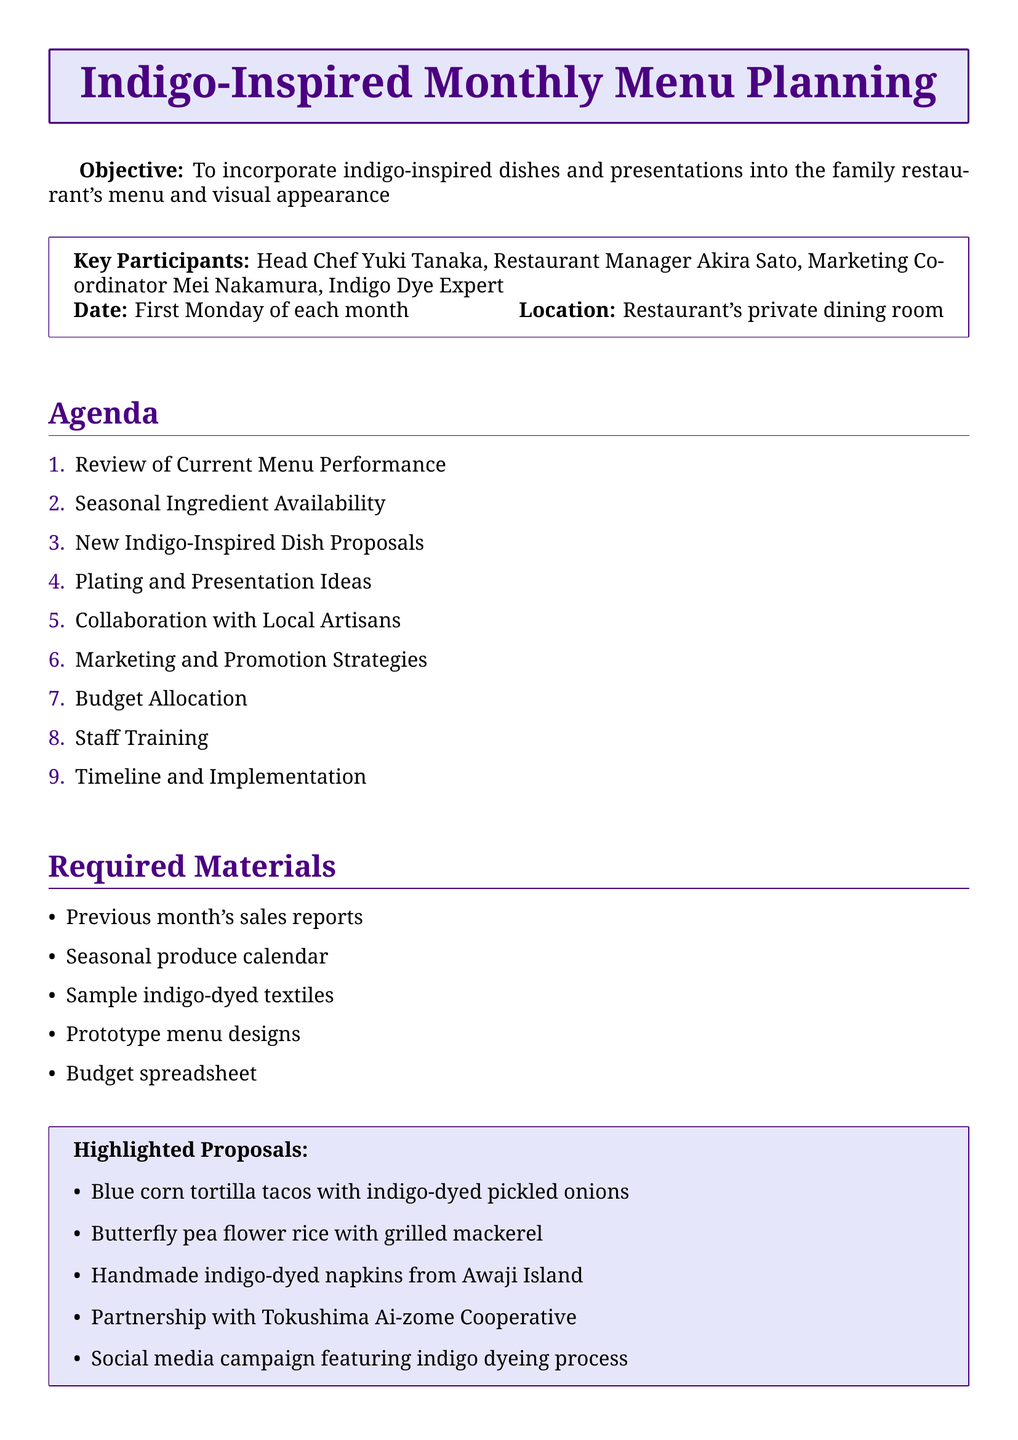What is the meeting title? The title of the meeting is stated at the beginning of the document.
Answer: Indigo-Inspired Monthly Menu Planning Who is the restaurant manager? The document lists the key participants, including the restaurant manager.
Answer: Akira Sato What is the meeting location? The document explicitly mentions the location of the meeting.
Answer: Restaurant's private dining room What is one new indigo-inspired dish proposal? The section on new dish proposals contains several items; one example can be selected.
Answer: Blue corn tortilla tacos with indigo-dyed pickled onions How often does the meeting occur? The document specifies the frequency of the meeting.
Answer: First Monday of each month What artisan collaboration is proposed? The agenda item suggests a partnership with a specific cooperative for an artisan collaboration.
Answer: Tokushima Ai-zome Cooperative What is the budget allocation focused on? The budget allocation item outlines key areas of expense related to the indigo theme.
Answer: New ingredients and specialty items What type of training is included in staff training? The staff training agenda item mentions specific educational focus areas.
Answer: Education on indigo dyeing history and techniques 